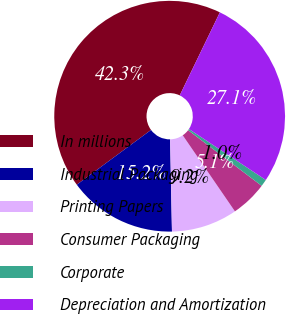Convert chart to OTSL. <chart><loc_0><loc_0><loc_500><loc_500><pie_chart><fcel>In millions<fcel>Industrial Packaging<fcel>Printing Papers<fcel>Consumer Packaging<fcel>Corporate<fcel>Depreciation and Amortization<nl><fcel>42.28%<fcel>15.21%<fcel>9.25%<fcel>5.12%<fcel>0.99%<fcel>27.15%<nl></chart> 